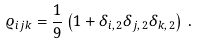Convert formula to latex. <formula><loc_0><loc_0><loc_500><loc_500>\varrho _ { i j k } = \frac { 1 } { 9 } \left ( 1 + \delta _ { i , \, 2 } \delta _ { j , \, 2 } \delta _ { k , \, 2 } \right ) \, .</formula> 